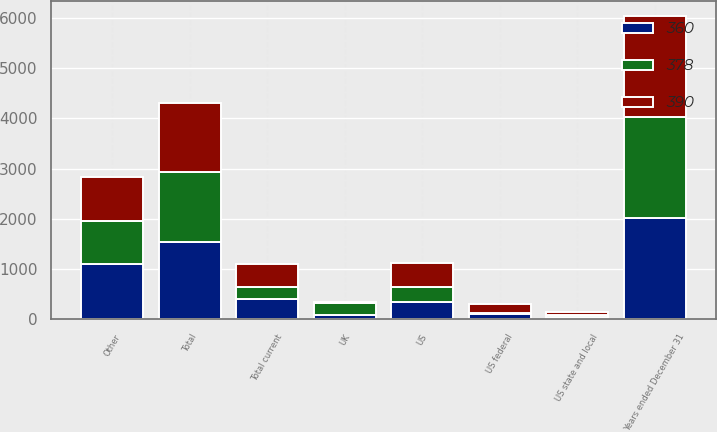Convert chart. <chart><loc_0><loc_0><loc_500><loc_500><stacked_bar_chart><ecel><fcel>Years ended December 31<fcel>UK<fcel>US<fcel>Other<fcel>Total<fcel>US federal<fcel>US state and local<fcel>Total current<nl><fcel>360<fcel>2013<fcel>96<fcel>349<fcel>1093<fcel>1538<fcel>111<fcel>52<fcel>404<nl><fcel>390<fcel>2012<fcel>36<fcel>468<fcel>876<fcel>1380<fcel>170<fcel>57<fcel>455<nl><fcel>378<fcel>2011<fcel>222<fcel>305<fcel>861<fcel>1388<fcel>17<fcel>35<fcel>235<nl></chart> 